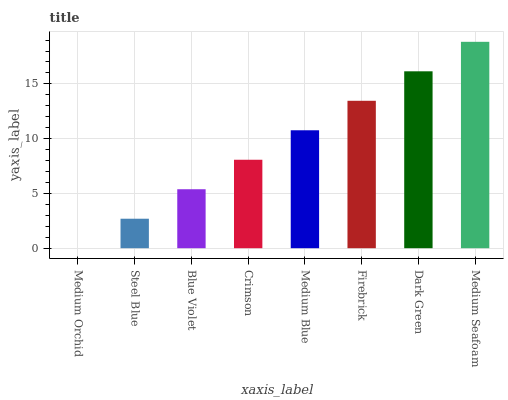Is Medium Orchid the minimum?
Answer yes or no. Yes. Is Medium Seafoam the maximum?
Answer yes or no. Yes. Is Steel Blue the minimum?
Answer yes or no. No. Is Steel Blue the maximum?
Answer yes or no. No. Is Steel Blue greater than Medium Orchid?
Answer yes or no. Yes. Is Medium Orchid less than Steel Blue?
Answer yes or no. Yes. Is Medium Orchid greater than Steel Blue?
Answer yes or no. No. Is Steel Blue less than Medium Orchid?
Answer yes or no. No. Is Medium Blue the high median?
Answer yes or no. Yes. Is Crimson the low median?
Answer yes or no. Yes. Is Steel Blue the high median?
Answer yes or no. No. Is Steel Blue the low median?
Answer yes or no. No. 